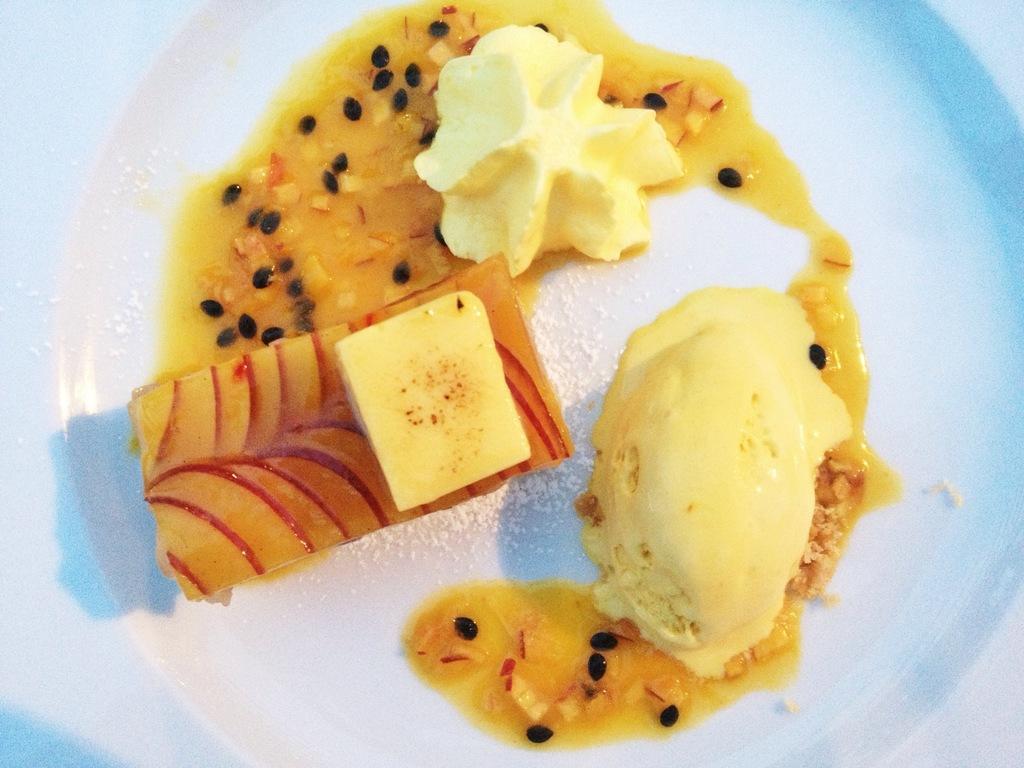Please provide a concise description of this image. In this image we can see ice cream, sweet and other food items on a plate. 